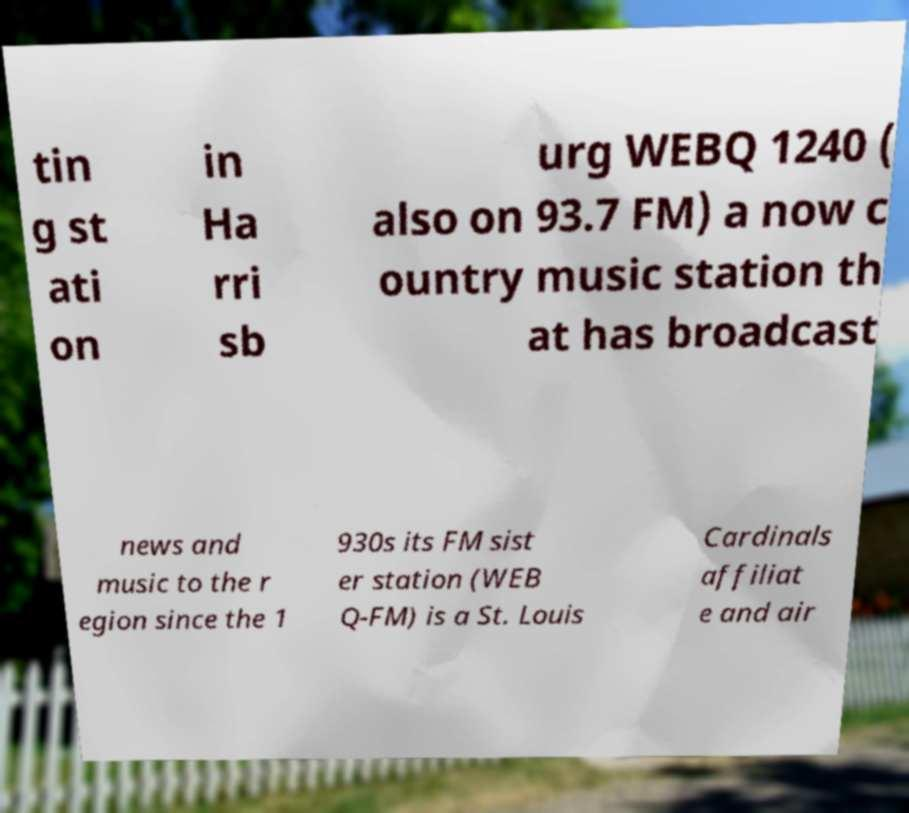Could you assist in decoding the text presented in this image and type it out clearly? tin g st ati on in Ha rri sb urg WEBQ 1240 ( also on 93.7 FM) a now c ountry music station th at has broadcast news and music to the r egion since the 1 930s its FM sist er station (WEB Q-FM) is a St. Louis Cardinals affiliat e and air 